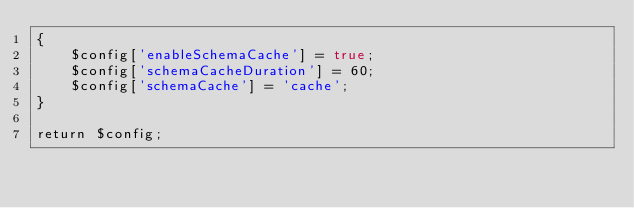Convert code to text. <code><loc_0><loc_0><loc_500><loc_500><_PHP_>{
    $config['enableSchemaCache'] = true;
    $config['schemaCacheDuration'] = 60;
    $config['schemaCache'] = 'cache';
}

return $config;</code> 